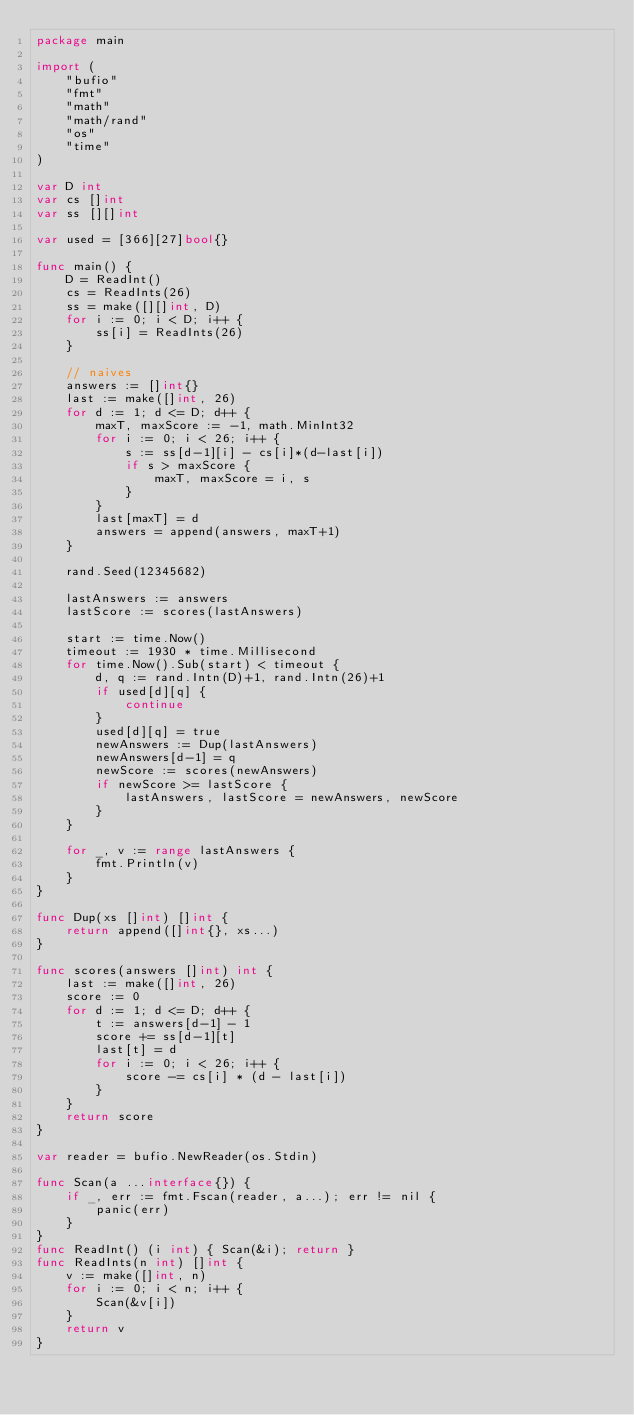Convert code to text. <code><loc_0><loc_0><loc_500><loc_500><_Go_>package main

import (
	"bufio"
	"fmt"
	"math"
	"math/rand"
	"os"
	"time"
)

var D int
var cs []int
var ss [][]int

var used = [366][27]bool{}

func main() {
	D = ReadInt()
	cs = ReadInts(26)
	ss = make([][]int, D)
	for i := 0; i < D; i++ {
		ss[i] = ReadInts(26)
	}

	// naives
	answers := []int{}
	last := make([]int, 26)
	for d := 1; d <= D; d++ {
		maxT, maxScore := -1, math.MinInt32
		for i := 0; i < 26; i++ {
			s := ss[d-1][i] - cs[i]*(d-last[i])
			if s > maxScore {
				maxT, maxScore = i, s
			}
		}
		last[maxT] = d
		answers = append(answers, maxT+1)
	}

	rand.Seed(12345682)

	lastAnswers := answers
	lastScore := scores(lastAnswers)

	start := time.Now()
	timeout := 1930 * time.Millisecond
	for time.Now().Sub(start) < timeout {
		d, q := rand.Intn(D)+1, rand.Intn(26)+1
		if used[d][q] {
			continue
		}
		used[d][q] = true
		newAnswers := Dup(lastAnswers)
		newAnswers[d-1] = q
		newScore := scores(newAnswers)
		if newScore >= lastScore {
			lastAnswers, lastScore = newAnswers, newScore
		}
	}

	for _, v := range lastAnswers {
		fmt.Println(v)
	}
}

func Dup(xs []int) []int {
	return append([]int{}, xs...)
}

func scores(answers []int) int {
	last := make([]int, 26)
	score := 0
	for d := 1; d <= D; d++ {
		t := answers[d-1] - 1
		score += ss[d-1][t]
		last[t] = d
		for i := 0; i < 26; i++ {
			score -= cs[i] * (d - last[i])
		}
	}
	return score
}

var reader = bufio.NewReader(os.Stdin)

func Scan(a ...interface{}) {
	if _, err := fmt.Fscan(reader, a...); err != nil {
		panic(err)
	}
}
func ReadInt() (i int) { Scan(&i); return }
func ReadInts(n int) []int {
	v := make([]int, n)
	for i := 0; i < n; i++ {
		Scan(&v[i])
	}
	return v
}
</code> 